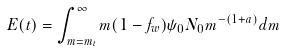<formula> <loc_0><loc_0><loc_500><loc_500>E ( t ) = \int _ { m = m _ { t } } ^ { \infty } m ( 1 - f _ { w } ) \psi _ { 0 } N _ { 0 } m ^ { - ( 1 + a ) } d m</formula> 